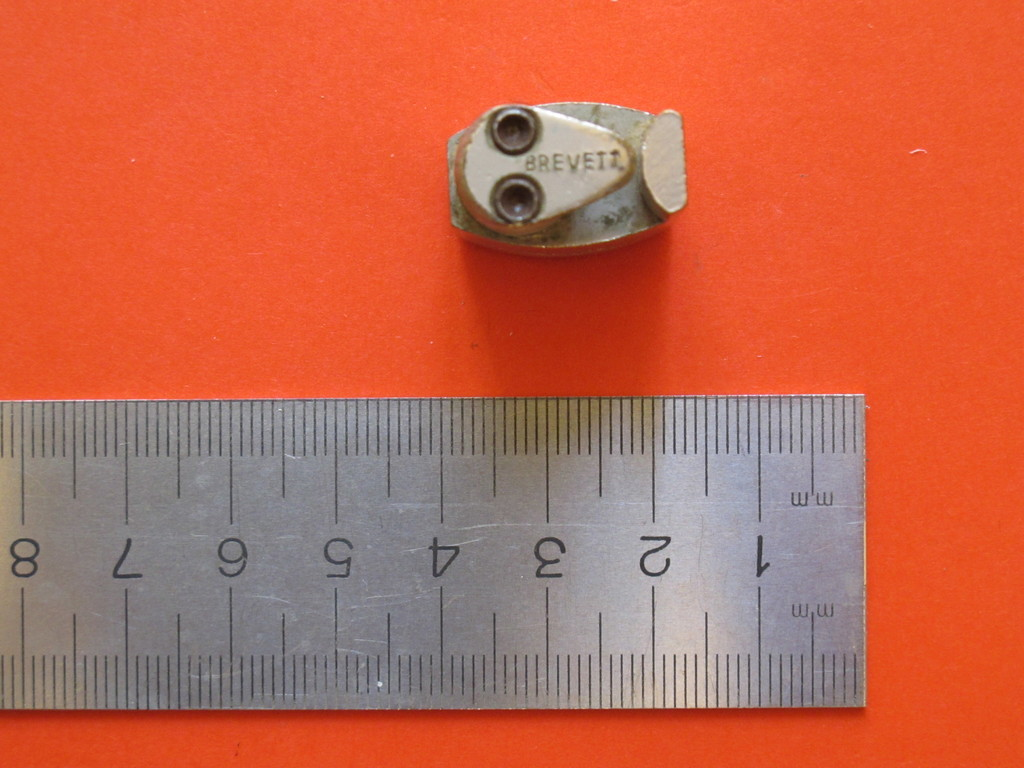How accurately can the measurements taken with the ruler in the image be considered? The ruler against the vivid orange background appears to be a precision tool typically used in engineering or construction to provide highly accurate measurements, essential for detailed work. 